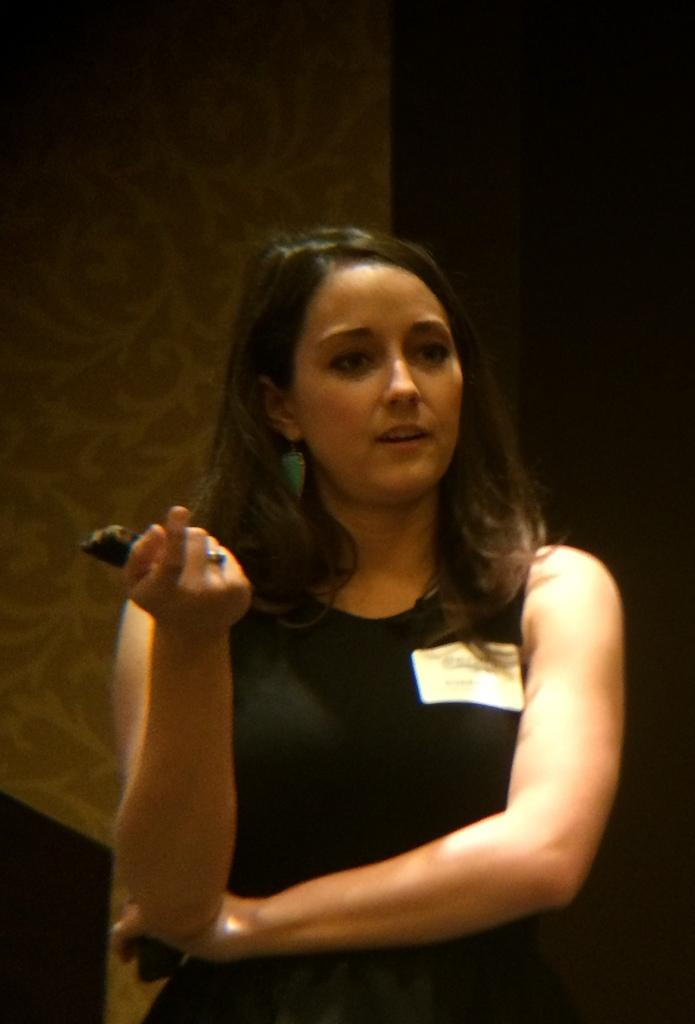What is the woman in the image doing? The woman is standing in the image. What is the woman holding in the image? The woman is holding a mobile in the image. What can be seen in the background of the image? There is a wall in the background of the image. What type of nail is the woman using to hang a painting in the image? There is no nail or painting present in the image. What kind of animal can be seen interacting with the woman in the image? There is no animal present in the image. 